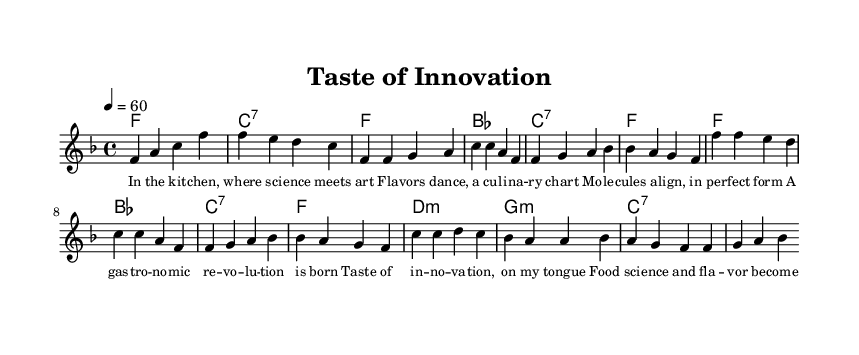What is the key signature of this music? The key signature is F major, which has one flat (B flat).
Answer: F major What is the time signature of this music? The time signature is 4/4, indicating four beats per measure.
Answer: 4/4 What is the tempo marking of this music? The tempo marking is quarter note equals 60, meaning there are 60 beats per minute.
Answer: 60 How many measures are in the verse section? The verse section consists of 8 measures in total, from the start to the end of the portion specified.
Answer: 8 How many chords are used in the chorus? The chorus features 3 distinct chord types: F, B flat, and C seventh.
Answer: 3 What is the primary thematic focus of the lyrics in this piece? The thematic focus revolves around the celebration of culinary innovation and the fusion of science and art in cooking.
Answer: Culinary innovation Which section contains the lyrics 'Taste of innovation'? These lyrics are found in the chorus section of the song.
Answer: Chorus 